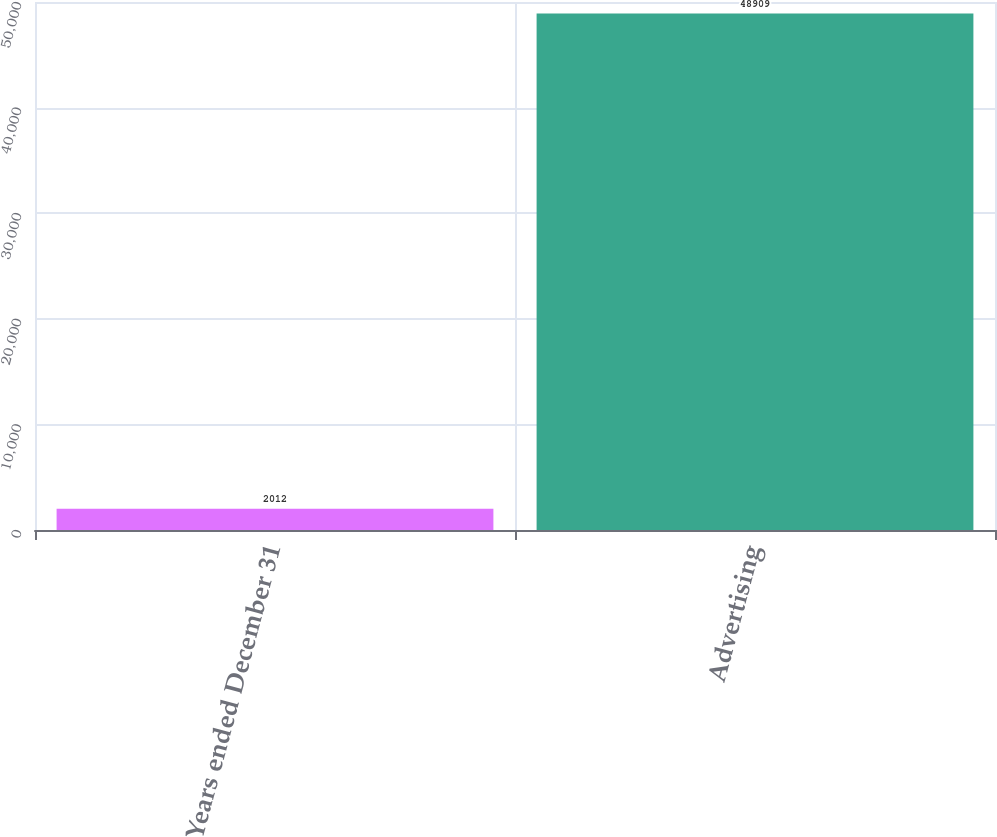Convert chart to OTSL. <chart><loc_0><loc_0><loc_500><loc_500><bar_chart><fcel>Years ended December 31<fcel>Advertising<nl><fcel>2012<fcel>48909<nl></chart> 